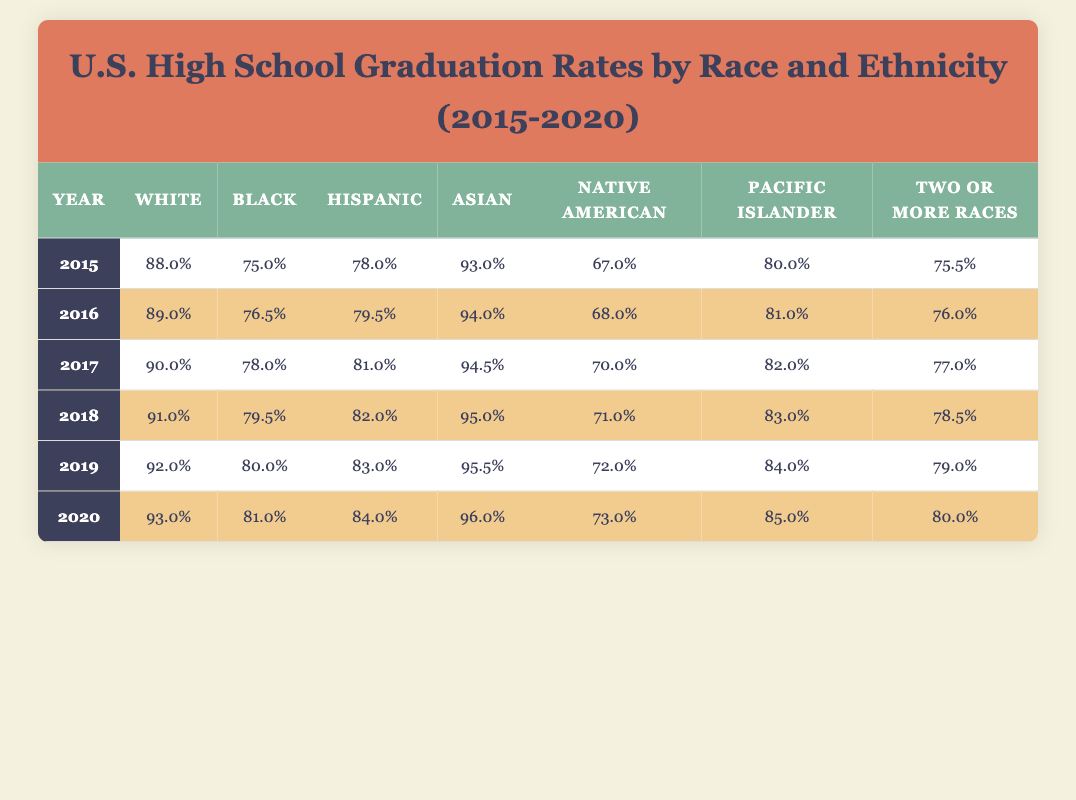What was the graduation rate for Black students in 2018? The table shows the column for Black students for the year 2018, which lists a graduation rate of 79.5%.
Answer: 79.5% What is the graduation rate of Asian students in 2020? The table reveals that for the year 2020, the graduation rate for Asian students is 96.0%.
Answer: 96.0% How much did the graduation rate for White students increase from 2015 to 2020? The graduation rate for White students in 2015 was 88.0%, and in 2020 it increased to 93.0%. The difference is 93.0 - 88.0 = 5.0.
Answer: 5.0 Is the graduation rate for Native American students higher in 2019 than it was in 2016? In 2019, the graduation rate for Native American students was 72.0%, while in 2016 it was 68.0%. Since 72.0 is greater than 68.0, the statement is true.
Answer: Yes What is the average graduation rate for Hispanic students over the years 2015 to 2020? The graduation rates for Hispanic students are 78.0%, 79.5%, 81.0%, 82.0%, 83.0%, and 84.0%. To find the average, sum these rates (78.0 + 79.5 + 81.0 + 82.0 + 83.0 + 84.0 = 487.5) and divide by the count of years (6). Thus, the average is 487.5 / 6 = 81.25.
Answer: 81.25 How did the graduation rates for students identifying as “Two or more races” change from 2015 to 2020? The rate for students identifying as “Two or more races” in 2015 was 75.5%, and in 2020, it increased to 80.0%. This shows an increase of 80.0 - 75.5 = 4.5%.
Answer: Increased by 4.5% 